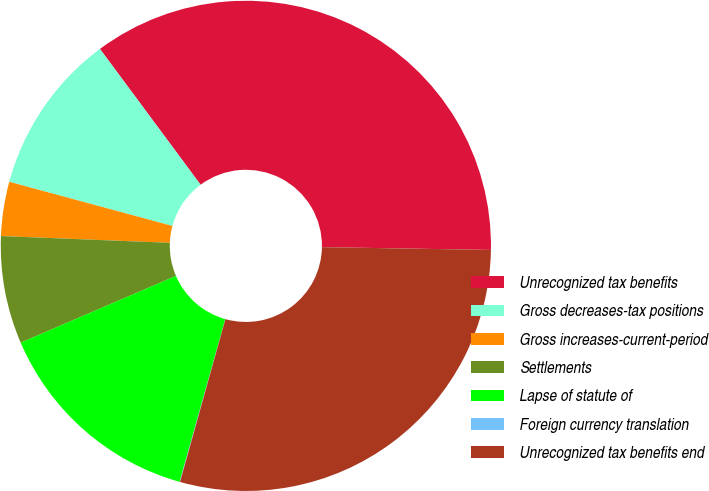Convert chart to OTSL. <chart><loc_0><loc_0><loc_500><loc_500><pie_chart><fcel>Unrecognized tax benefits<fcel>Gross decreases-tax positions<fcel>Gross increases-current-period<fcel>Settlements<fcel>Lapse of statute of<fcel>Foreign currency translation<fcel>Unrecognized tax benefits end<nl><fcel>35.41%<fcel>10.64%<fcel>3.57%<fcel>7.1%<fcel>14.18%<fcel>0.03%<fcel>29.06%<nl></chart> 